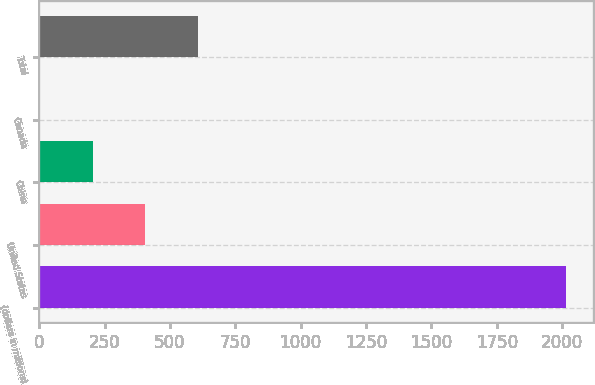Convert chart. <chart><loc_0><loc_0><loc_500><loc_500><bar_chart><fcel>(dollars in millions)<fcel>United States<fcel>China<fcel>Canada<fcel>Total<nl><fcel>2016<fcel>405.68<fcel>204.39<fcel>3.1<fcel>606.97<nl></chart> 